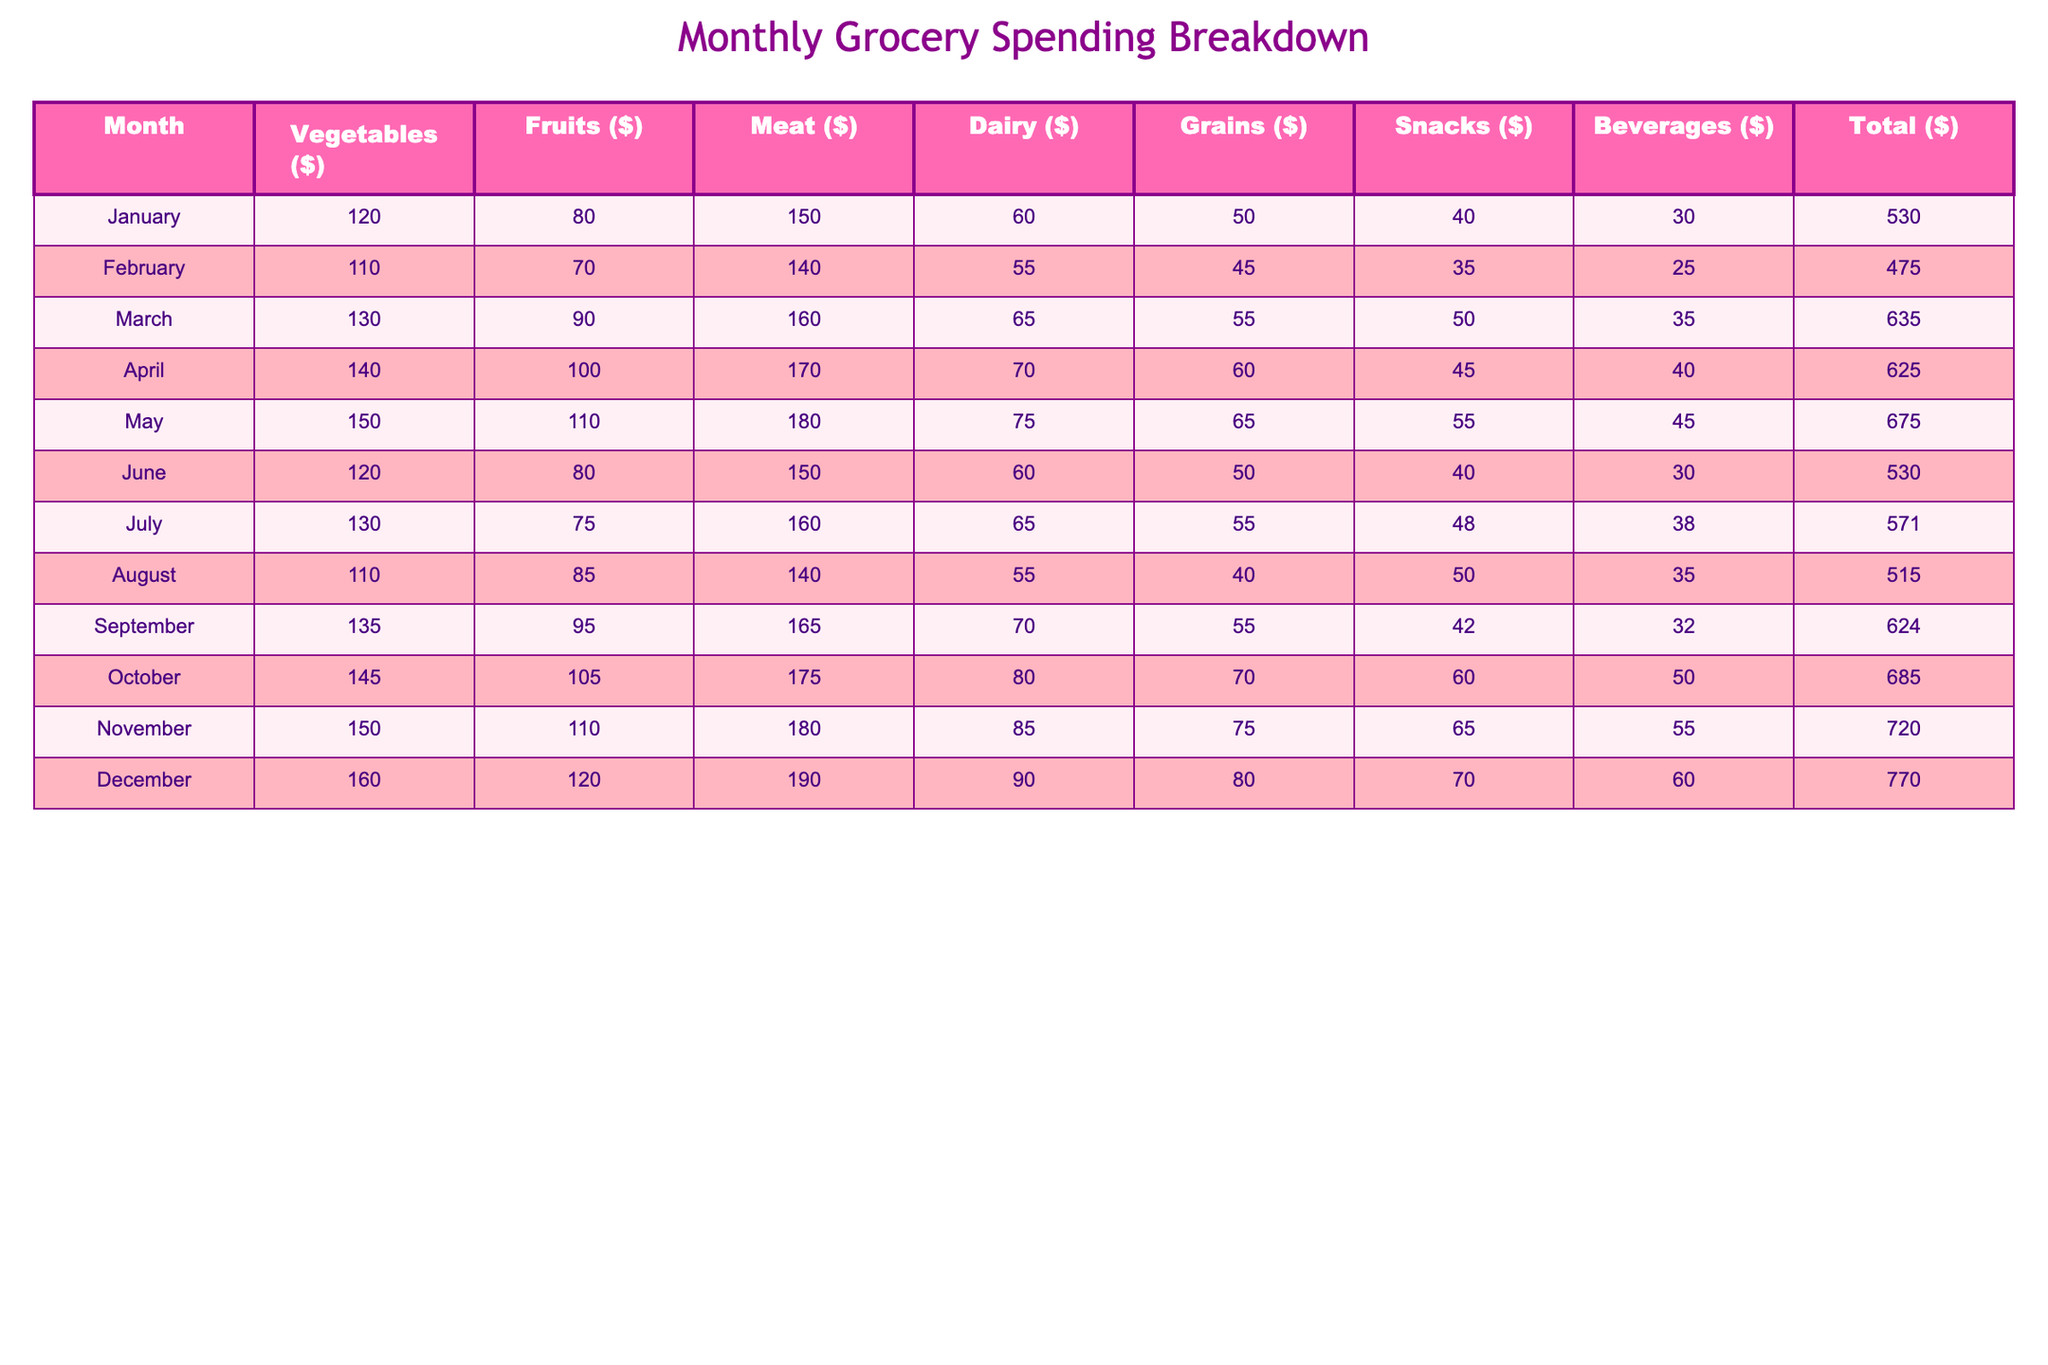What was the total spending on groceries in December? The table shows that the total spending in December is listed as $770.
Answer: 770 Which month had the highest spending on meat? By looking at the meat column, December shows the highest value of $190 compared to other months.
Answer: December What is the average monthly spending on dairy? The total dairy spending for the year is calculated as (60 + 55 + 65 + 70 + 75 + 60 + 65 + 55 + 80 + 90 + 85 + 90) = 865. Since there are 12 months, the average is 865 / 12 = 72.08, rounded to 72.
Answer: 72 Did the total spending exceed $600 in any month? By checking the total column, we see that the spending exceeded $600 in May ($675), October ($685), November ($720), and December ($770). Therefore, the answer is yes.
Answer: Yes In which month was the spending on snacks the lowest? The snacks column shows the minimum value of $35, which occurs in February and August. However, February is the first occurrence, so the answer is February.
Answer: February What is the difference in spending on vegetables between the highest month and the lowest month? The highest spending on vegetables is in December ($160), and the lowest is in February ($110). The difference is 160 - 110 = 50.
Answer: 50 What was the total spending on beverages in the first half of the year? Summing the beverages column from January to June gives us: 30 + 25 + 35 + 40 + 45 + 30 = 205. This is the total for the first half of the year.
Answer: 205 How many more dollars were spent on grains in October than in January? In October, the spending on grains is $70, and in January, it is $50. The difference is calculated as 70 - 50 = 20.
Answer: 20 Which category had the highest total spending throughout the year? By summing each category, we find: Vegetables = 1,545, Fruits = 1,030, Meat = 1,890, Dairy = 885, Grains = 755, Snacks = 615, Beverages = 485. The highest total is for the meat category, totaling $1,890.
Answer: Meat 